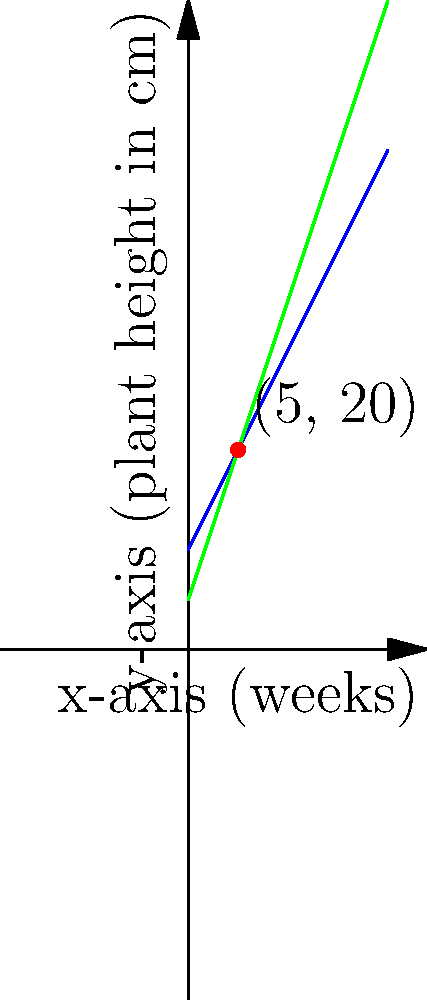Two cannabis strains, Indica and Sativa, are being grown in a sustainable indoor facility. The growth patterns of these strains can be represented by linear equations. The Indica strain's growth is modeled by the equation $y = 2x + 10$, where $x$ is the number of weeks and $y$ is the plant height in centimeters. The Sativa strain's growth is modeled by $y = 3x + 5$. At what point do these two growth patterns intersect, and what does this intersection represent in terms of sustainable cannabis cultivation? To find the intersection point of these two lines, we need to solve the system of equations:

1) Indica strain: $y = 2x + 10$
2) Sativa strain: $y = 3x + 5$

At the intersection point, the $x$ and $y$ values will be the same for both equations. So we can set them equal to each other:

$2x + 10 = 3x + 5$

Now, let's solve for $x$:

$2x + 10 = 3x + 5$
$10 - 5 = 3x - 2x$
$5 = x$

So, the $x$-coordinate of the intersection point is 5 weeks.

To find the $y$-coordinate, we can plug $x = 5$ into either of the original equations. Let's use the Indica strain equation:

$y = 2(5) + 10 = 10 + 10 = 20$

Therefore, the intersection point is (5, 20).

This point represents the time (5 weeks) and height (20 cm) at which both strains will have the same height. In terms of sustainable cultivation, this information can be used to optimize growing space, lighting, and resource allocation, as it indicates when the two strains will require similar conditions despite their different growth rates.
Answer: (5, 20) 